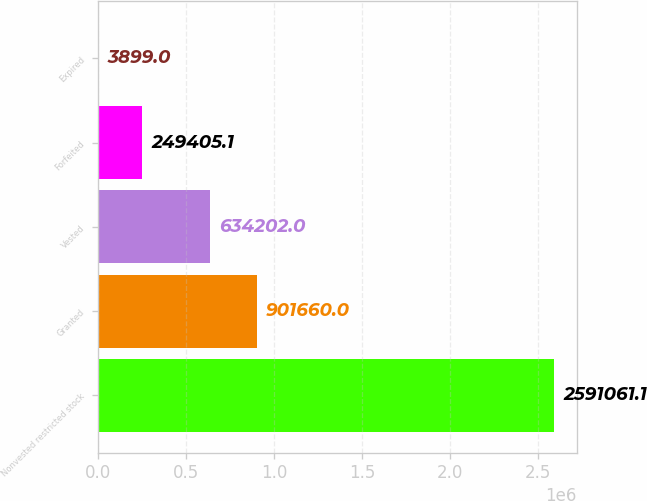Convert chart. <chart><loc_0><loc_0><loc_500><loc_500><bar_chart><fcel>Nonvested restricted stock<fcel>Granted<fcel>Vested<fcel>Forfeited<fcel>Expired<nl><fcel>2.59106e+06<fcel>901660<fcel>634202<fcel>249405<fcel>3899<nl></chart> 